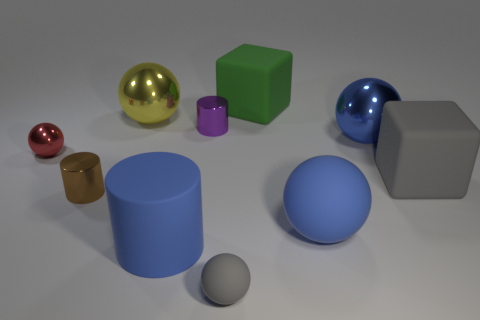Subtract all purple cubes. How many blue balls are left? 2 Subtract all big spheres. How many spheres are left? 2 Subtract all yellow balls. How many balls are left? 4 Subtract all yellow cylinders. Subtract all green cubes. How many cylinders are left? 3 Subtract all cylinders. How many objects are left? 7 Add 6 small red spheres. How many small red spheres exist? 7 Subtract 1 purple cylinders. How many objects are left? 9 Subtract all small metal spheres. Subtract all gray matte cubes. How many objects are left? 8 Add 8 blue spheres. How many blue spheres are left? 10 